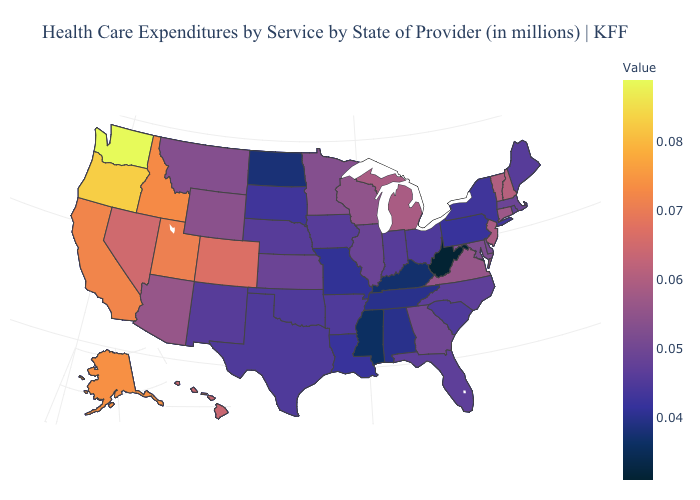Does Pennsylvania have the lowest value in the Northeast?
Write a very short answer. Yes. Does Colorado have a lower value than Washington?
Give a very brief answer. Yes. 